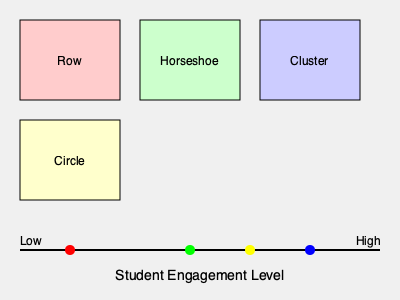Based on the classroom seating arrangements shown in the image, which configuration is likely to promote the highest level of student engagement in a community college setting? To determine which seating arrangement promotes the highest level of student engagement, let's analyze each configuration:

1. Traditional Row Seating:
   - Represented by the red box and red dot on the engagement scale
   - Located at the far left of the scale, indicating the lowest engagement level
   - Typically limits interaction between students and reduces participation

2. Horseshoe/U-shape Seating:
   - Represented by the green box and green dot on the engagement scale
   - Located towards the right side of the scale, suggesting high engagement
   - Allows for better eye contact and interaction between students and instructor

3. Cluster/Group Seating:
   - Represented by the blue box and blue dot on the engagement scale
   - Located at the far right of the scale, indicating the highest engagement level
   - Facilitates collaborative learning and peer-to-peer interaction

4. Circle Seating:
   - Represented by the yellow box and yellow dot on the engagement scale
   - Located between horseshoe and cluster arrangements on the scale
   - Promotes equal participation and encourages whole-class discussions

Based on the engagement scale in the image, the Cluster/Group seating arrangement (blue) is positioned furthest to the right, indicating the highest level of student engagement. This configuration allows for easy collaboration, group work, and peer learning, which are particularly beneficial in a community college setting where diverse student backgrounds and experiences can contribute to rich discussions and problem-solving activities.
Answer: Cluster/Group seating 